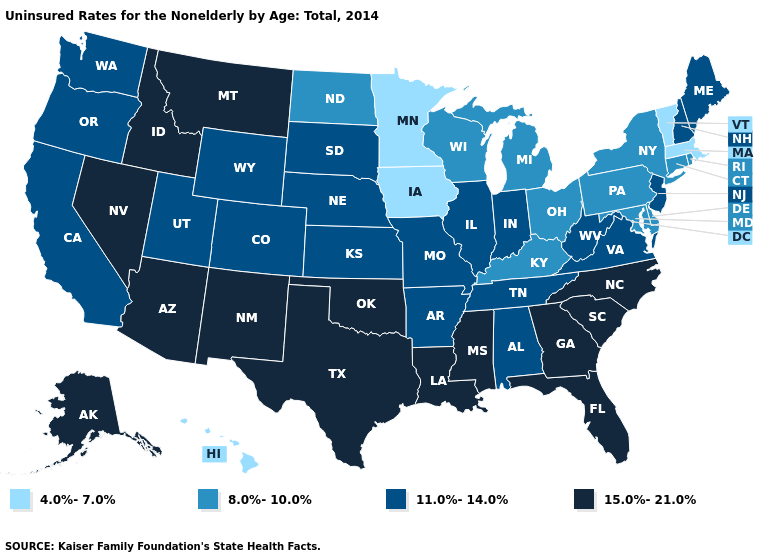What is the value of Wisconsin?
Be succinct. 8.0%-10.0%. What is the value of Arizona?
Keep it brief. 15.0%-21.0%. What is the value of Iowa?
Answer briefly. 4.0%-7.0%. Among the states that border New Jersey , which have the highest value?
Quick response, please. Delaware, New York, Pennsylvania. Name the states that have a value in the range 11.0%-14.0%?
Write a very short answer. Alabama, Arkansas, California, Colorado, Illinois, Indiana, Kansas, Maine, Missouri, Nebraska, New Hampshire, New Jersey, Oregon, South Dakota, Tennessee, Utah, Virginia, Washington, West Virginia, Wyoming. Among the states that border Iowa , does Minnesota have the highest value?
Keep it brief. No. What is the value of Rhode Island?
Short answer required. 8.0%-10.0%. Does Florida have the lowest value in the USA?
Quick response, please. No. Name the states that have a value in the range 8.0%-10.0%?
Write a very short answer. Connecticut, Delaware, Kentucky, Maryland, Michigan, New York, North Dakota, Ohio, Pennsylvania, Rhode Island, Wisconsin. Name the states that have a value in the range 8.0%-10.0%?
Quick response, please. Connecticut, Delaware, Kentucky, Maryland, Michigan, New York, North Dakota, Ohio, Pennsylvania, Rhode Island, Wisconsin. Does New Jersey have the highest value in the Northeast?
Concise answer only. Yes. How many symbols are there in the legend?
Write a very short answer. 4. What is the highest value in the USA?
Quick response, please. 15.0%-21.0%. Does New Hampshire have the lowest value in the Northeast?
Be succinct. No. Which states hav the highest value in the South?
Give a very brief answer. Florida, Georgia, Louisiana, Mississippi, North Carolina, Oklahoma, South Carolina, Texas. 